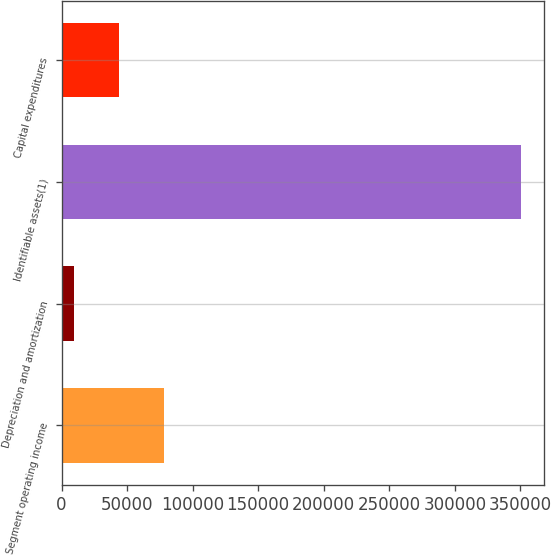Convert chart to OTSL. <chart><loc_0><loc_0><loc_500><loc_500><bar_chart><fcel>Segment operating income<fcel>Depreciation and amortization<fcel>Identifiable assets(1)<fcel>Capital expenditures<nl><fcel>77818.4<fcel>9568<fcel>350820<fcel>43693.2<nl></chart> 